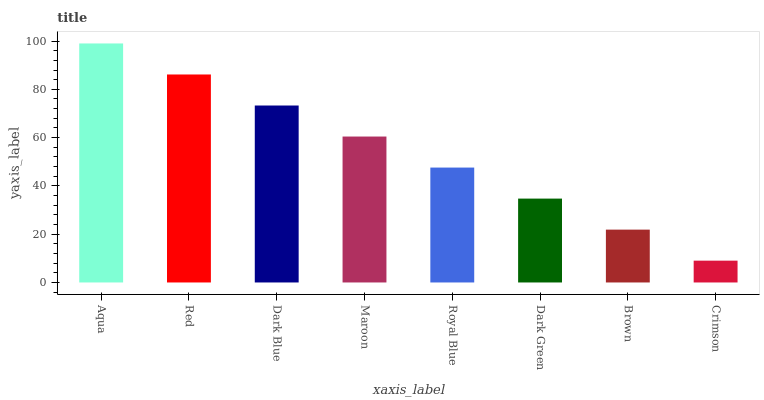Is Crimson the minimum?
Answer yes or no. Yes. Is Aqua the maximum?
Answer yes or no. Yes. Is Red the minimum?
Answer yes or no. No. Is Red the maximum?
Answer yes or no. No. Is Aqua greater than Red?
Answer yes or no. Yes. Is Red less than Aqua?
Answer yes or no. Yes. Is Red greater than Aqua?
Answer yes or no. No. Is Aqua less than Red?
Answer yes or no. No. Is Maroon the high median?
Answer yes or no. Yes. Is Royal Blue the low median?
Answer yes or no. Yes. Is Dark Green the high median?
Answer yes or no. No. Is Crimson the low median?
Answer yes or no. No. 